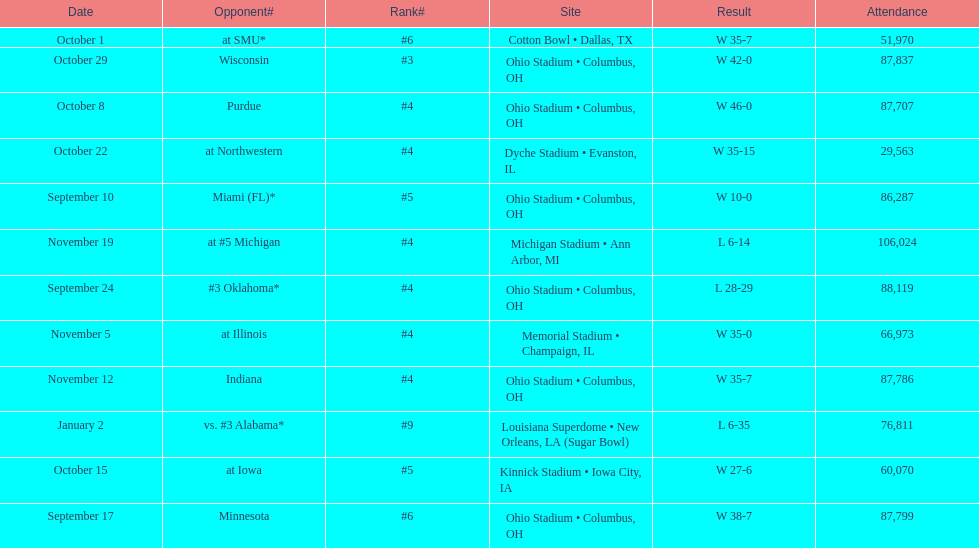Which date was attended by the most people? November 19. 